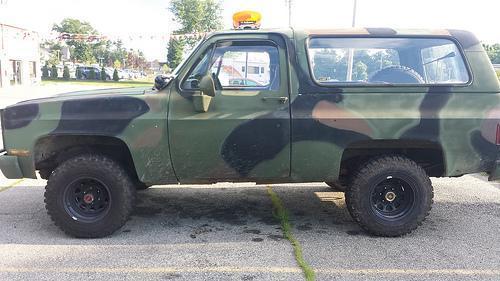How many tires can be seen?
Give a very brief answer. 2. 